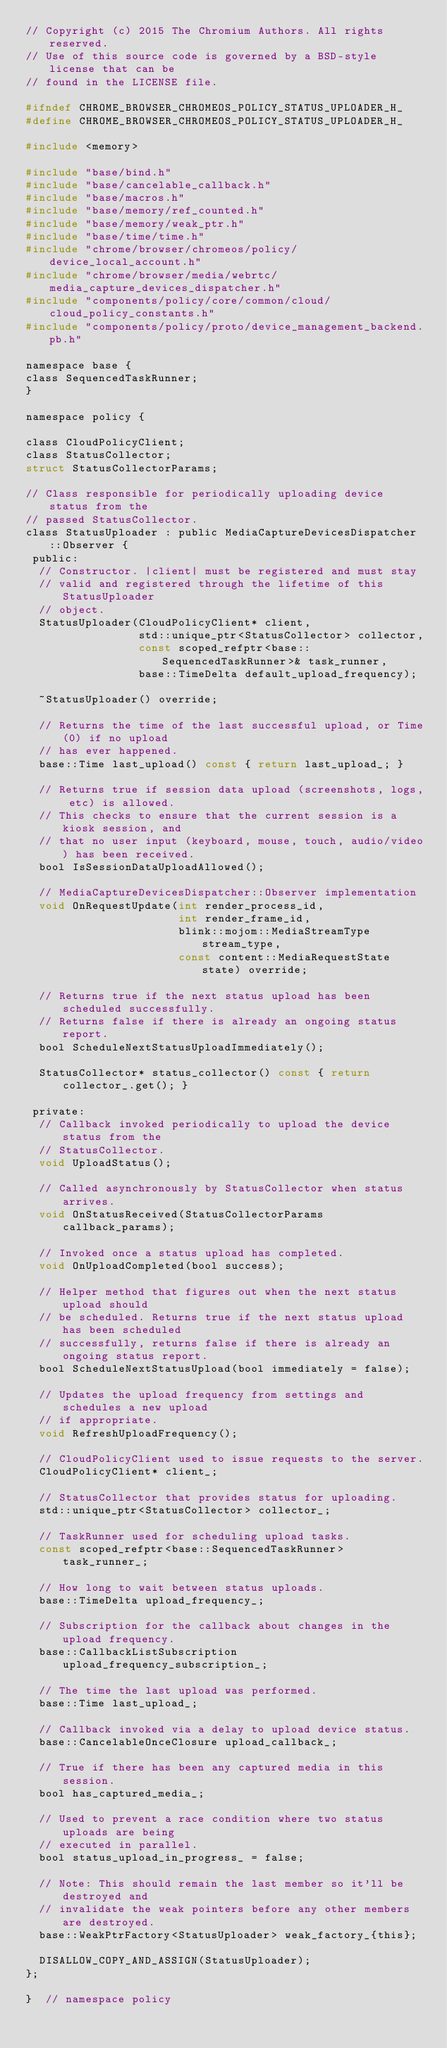<code> <loc_0><loc_0><loc_500><loc_500><_C_>// Copyright (c) 2015 The Chromium Authors. All rights reserved.
// Use of this source code is governed by a BSD-style license that can be
// found in the LICENSE file.

#ifndef CHROME_BROWSER_CHROMEOS_POLICY_STATUS_UPLOADER_H_
#define CHROME_BROWSER_CHROMEOS_POLICY_STATUS_UPLOADER_H_

#include <memory>

#include "base/bind.h"
#include "base/cancelable_callback.h"
#include "base/macros.h"
#include "base/memory/ref_counted.h"
#include "base/memory/weak_ptr.h"
#include "base/time/time.h"
#include "chrome/browser/chromeos/policy/device_local_account.h"
#include "chrome/browser/media/webrtc/media_capture_devices_dispatcher.h"
#include "components/policy/core/common/cloud/cloud_policy_constants.h"
#include "components/policy/proto/device_management_backend.pb.h"

namespace base {
class SequencedTaskRunner;
}

namespace policy {

class CloudPolicyClient;
class StatusCollector;
struct StatusCollectorParams;

// Class responsible for periodically uploading device status from the
// passed StatusCollector.
class StatusUploader : public MediaCaptureDevicesDispatcher::Observer {
 public:
  // Constructor. |client| must be registered and must stay
  // valid and registered through the lifetime of this StatusUploader
  // object.
  StatusUploader(CloudPolicyClient* client,
                 std::unique_ptr<StatusCollector> collector,
                 const scoped_refptr<base::SequencedTaskRunner>& task_runner,
                 base::TimeDelta default_upload_frequency);

  ~StatusUploader() override;

  // Returns the time of the last successful upload, or Time(0) if no upload
  // has ever happened.
  base::Time last_upload() const { return last_upload_; }

  // Returns true if session data upload (screenshots, logs, etc) is allowed.
  // This checks to ensure that the current session is a kiosk session, and
  // that no user input (keyboard, mouse, touch, audio/video) has been received.
  bool IsSessionDataUploadAllowed();

  // MediaCaptureDevicesDispatcher::Observer implementation
  void OnRequestUpdate(int render_process_id,
                       int render_frame_id,
                       blink::mojom::MediaStreamType stream_type,
                       const content::MediaRequestState state) override;

  // Returns true if the next status upload has been scheduled successfully.
  // Returns false if there is already an ongoing status report.
  bool ScheduleNextStatusUploadImmediately();

  StatusCollector* status_collector() const { return collector_.get(); }

 private:
  // Callback invoked periodically to upload the device status from the
  // StatusCollector.
  void UploadStatus();

  // Called asynchronously by StatusCollector when status arrives.
  void OnStatusReceived(StatusCollectorParams callback_params);

  // Invoked once a status upload has completed.
  void OnUploadCompleted(bool success);

  // Helper method that figures out when the next status upload should
  // be scheduled. Returns true if the next status upload has been scheduled
  // successfully, returns false if there is already an ongoing status report.
  bool ScheduleNextStatusUpload(bool immediately = false);

  // Updates the upload frequency from settings and schedules a new upload
  // if appropriate.
  void RefreshUploadFrequency();

  // CloudPolicyClient used to issue requests to the server.
  CloudPolicyClient* client_;

  // StatusCollector that provides status for uploading.
  std::unique_ptr<StatusCollector> collector_;

  // TaskRunner used for scheduling upload tasks.
  const scoped_refptr<base::SequencedTaskRunner> task_runner_;

  // How long to wait between status uploads.
  base::TimeDelta upload_frequency_;

  // Subscription for the callback about changes in the upload frequency.
  base::CallbackListSubscription upload_frequency_subscription_;

  // The time the last upload was performed.
  base::Time last_upload_;

  // Callback invoked via a delay to upload device status.
  base::CancelableOnceClosure upload_callback_;

  // True if there has been any captured media in this session.
  bool has_captured_media_;

  // Used to prevent a race condition where two status uploads are being
  // executed in parallel.
  bool status_upload_in_progress_ = false;

  // Note: This should remain the last member so it'll be destroyed and
  // invalidate the weak pointers before any other members are destroyed.
  base::WeakPtrFactory<StatusUploader> weak_factory_{this};

  DISALLOW_COPY_AND_ASSIGN(StatusUploader);
};

}  // namespace policy
</code> 